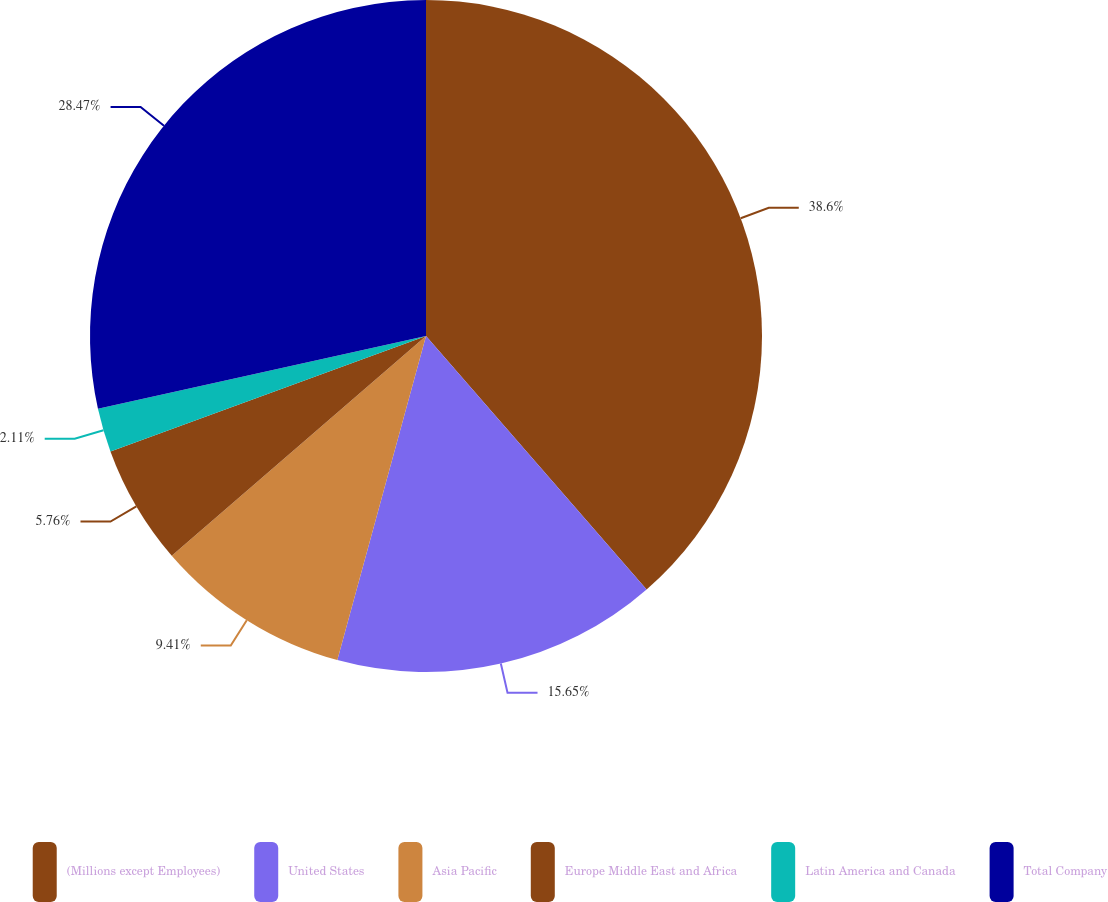Convert chart to OTSL. <chart><loc_0><loc_0><loc_500><loc_500><pie_chart><fcel>(Millions except Employees)<fcel>United States<fcel>Asia Pacific<fcel>Europe Middle East and Africa<fcel>Latin America and Canada<fcel>Total Company<nl><fcel>38.6%<fcel>15.65%<fcel>9.41%<fcel>5.76%<fcel>2.11%<fcel>28.47%<nl></chart> 